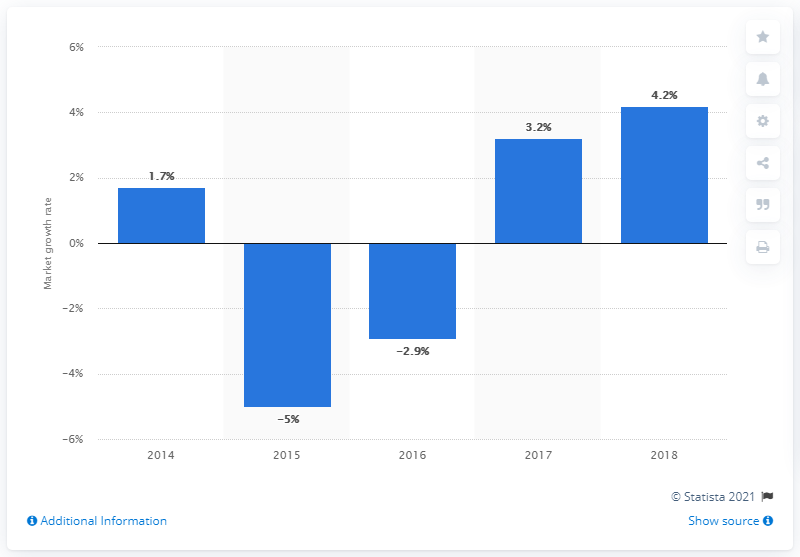List a handful of essential elements in this visual. The growth of the Russian public catering market reached its lowest point in 2015. The volume of the Russian public catering market grew by 4.2% in 2018. 